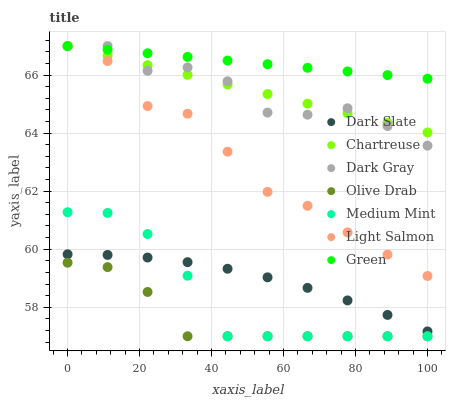Does Olive Drab have the minimum area under the curve?
Answer yes or no. Yes. Does Green have the maximum area under the curve?
Answer yes or no. Yes. Does Light Salmon have the minimum area under the curve?
Answer yes or no. No. Does Light Salmon have the maximum area under the curve?
Answer yes or no. No. Is Green the smoothest?
Answer yes or no. Yes. Is Dark Gray the roughest?
Answer yes or no. Yes. Is Light Salmon the smoothest?
Answer yes or no. No. Is Light Salmon the roughest?
Answer yes or no. No. Does Medium Mint have the lowest value?
Answer yes or no. Yes. Does Light Salmon have the lowest value?
Answer yes or no. No. Does Green have the highest value?
Answer yes or no. Yes. Does Dark Slate have the highest value?
Answer yes or no. No. Is Dark Slate less than Dark Gray?
Answer yes or no. Yes. Is Dark Gray greater than Olive Drab?
Answer yes or no. Yes. Does Light Salmon intersect Chartreuse?
Answer yes or no. Yes. Is Light Salmon less than Chartreuse?
Answer yes or no. No. Is Light Salmon greater than Chartreuse?
Answer yes or no. No. Does Dark Slate intersect Dark Gray?
Answer yes or no. No. 